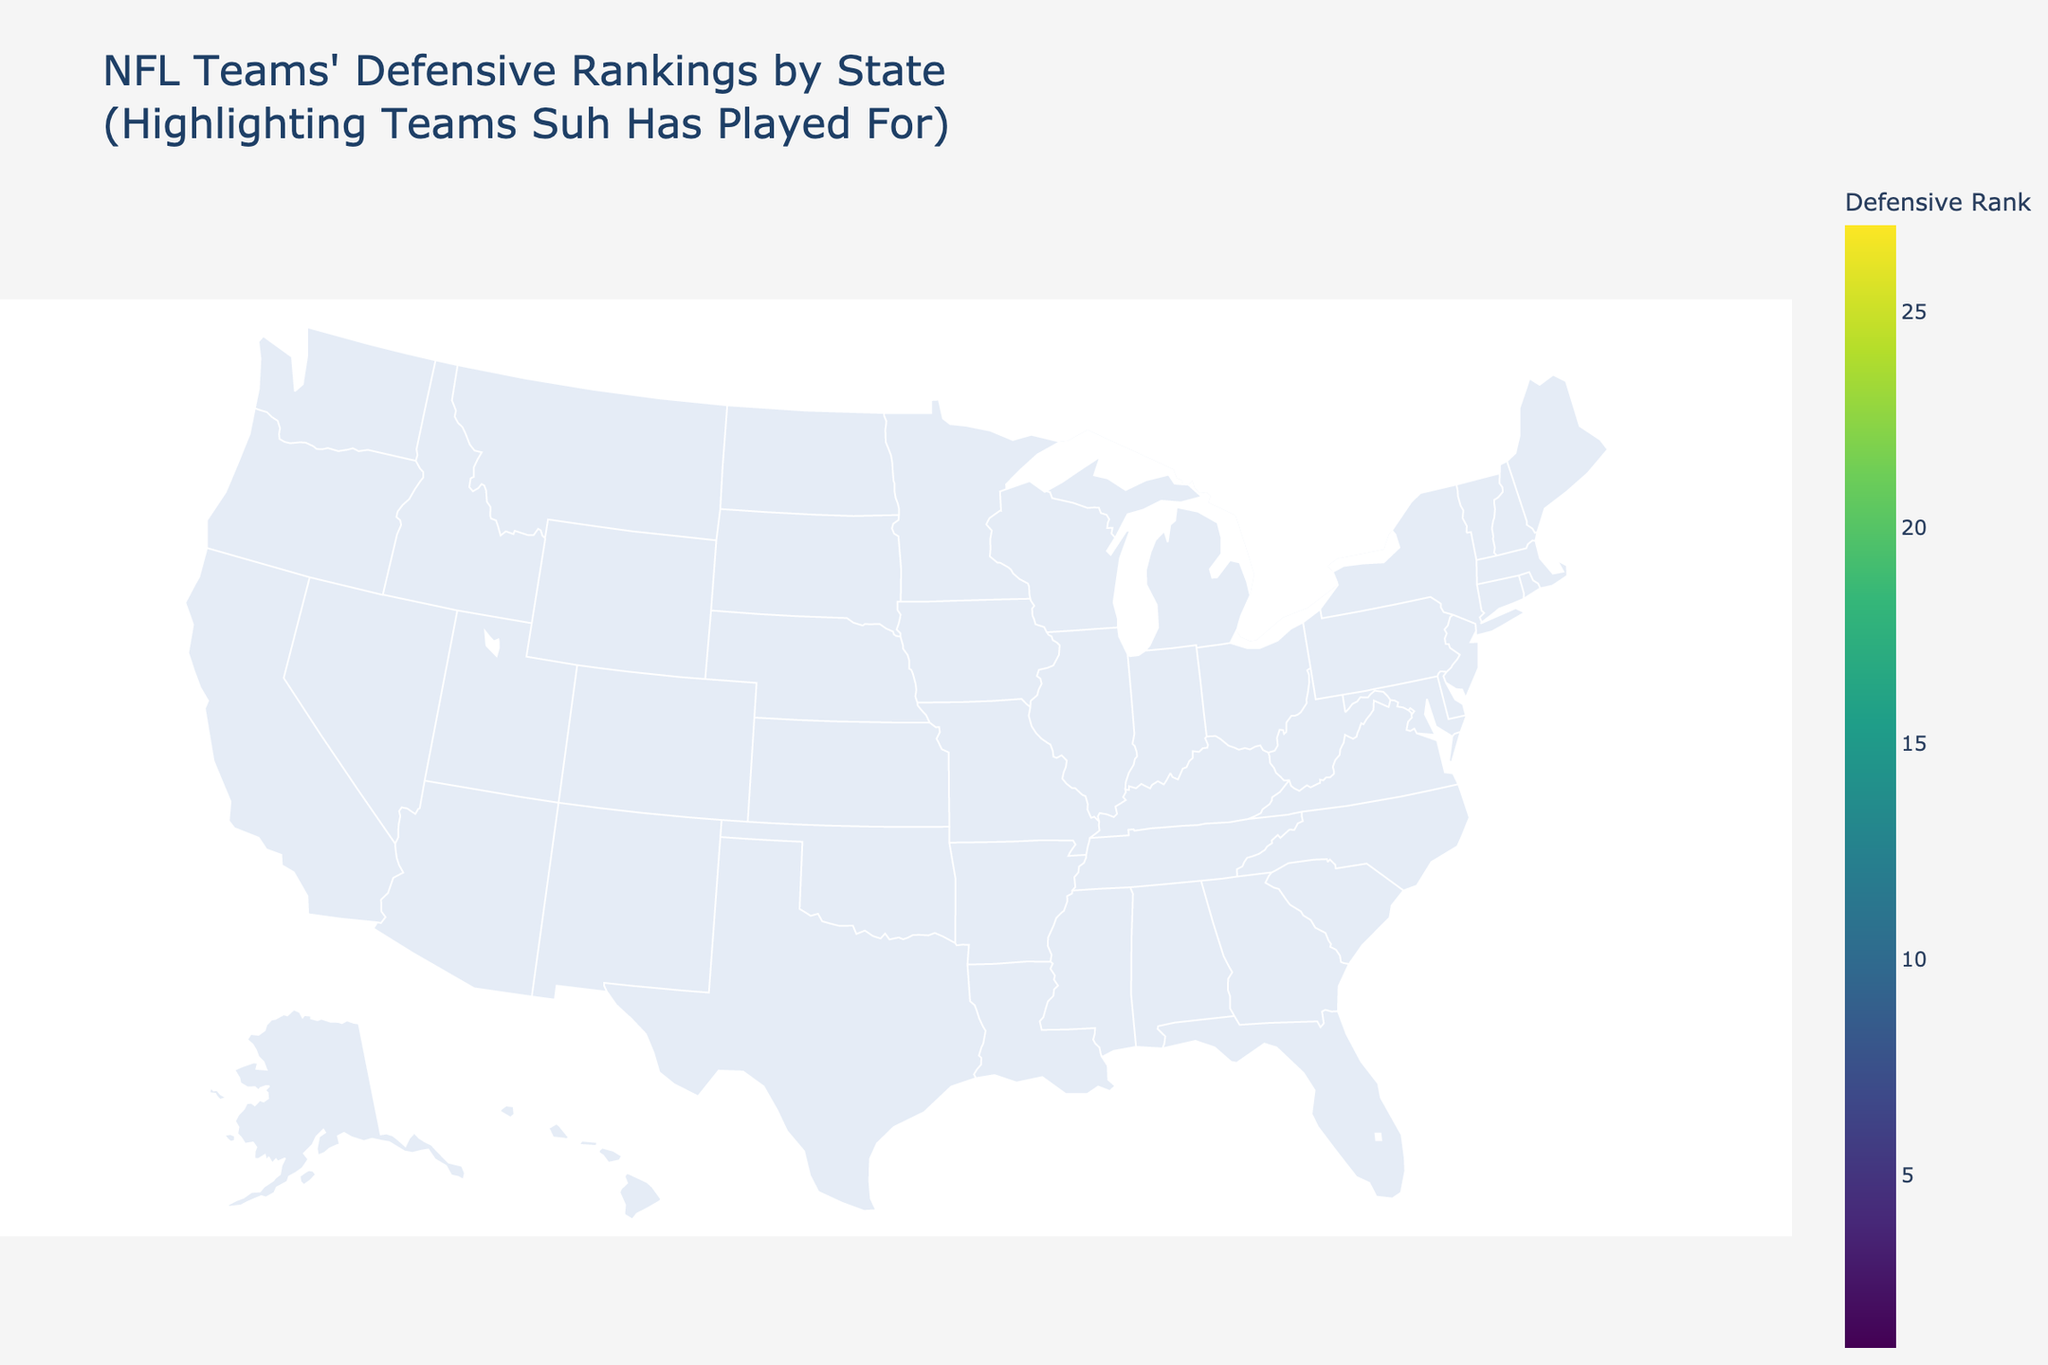Which team has the highest defensive ranking? The figure shows defensive rankings by state. The Baltimore Ravens in Maryland are shown with the highest defensive rank, which is 1.
Answer: Baltimore Ravens In which states has Ndamukong Suh played for teams, and what are their defensive ranks? The states where Suh has played are highlighted with markers. He has played for teams in Michigan (Detroit Lions - rank 3), Florida (Miami Dolphins - rank 25), California (Los Angeles Rams - rank 19), and Pennsylvania (Philadelphia Eagles - rank 7).
Answer: Michigan (3), Florida (25), California (19), Pennsylvania (7) Compare the defensive rankings of the teams in New York and Michigan. Which is better? The figure shows that the Buffalo Bills in New York have a defensive rank of 2, whereas the Detroit Lions in Michigan have a defensive rank of 3. Higher rank indicates a better defense, so New York (Buffalo Bills) has a better defensive rank.
Answer: Buffalo Bills What is the average defensive rank of the teams that Ndamukong Suh played for? Suh has played for teams with the following ranks: Michigan (3), Florida (25), California (19), and Pennsylvania (7). The average rank is calculated as (3 + 25 + 19 + 7) / 4 = 54 / 4 = 13.5.
Answer: 13.5 What's the defensive rank range of all the teams shown on the figure? The figure shows the defensive ranks as color gradients. The lowest rank is 1 (Baltimore Ravens) and the highest rank is 27 (Atlanta Falcons), making the range from 1 to 27.
Answer: 1 to 27 Which state has the team with the lowest defensive ranking, and what is the team's rank? The figure displays defensive rankings using colors. The Atlanta Falcons in Georgia have the lowest rank visible on the map, which is 27.
Answer: Georgia, rank 27 Considering only the teams Suh played for, which team has the worst defensive rank? The figure highlights the teams Suh has played for. The Miami Dolphins in Florida have the worst defensive rank among these teams, with a rank of 25.
Answer: Miami Dolphins How does the defensive rank of the Philadelphia Eagles compare to the defensive rank of the Seattle Seahawks? Based on the figure, the Philadelphia Eagles have a defensive rank of 7, while the Seattle Seahawks in Washington have a defensive rank of 11. Therefore, the Eagles have a better rank than the Seahawks.
Answer: Philadelphia Eagles What's the color range on the map representing in terms of defensive rank? The colors shown on the map range from lighter shades indicating higher ranks (e.g., ranks close to 1) to darker shades indicating lower ranks (e.g., ranks closer to 27).
Answer: High rank (lighter) to low rank (darker) Which team is ranked better defensively: the Green Bay Packers or the Cleveland Browns? According to the figure, the Green Bay Packers in Wisconsin have a defensive rank of 17, while the Cleveland Browns in Ohio have a defensive rank of 14. The Browns have a better defensive rank.
Answer: Cleveland Browns 